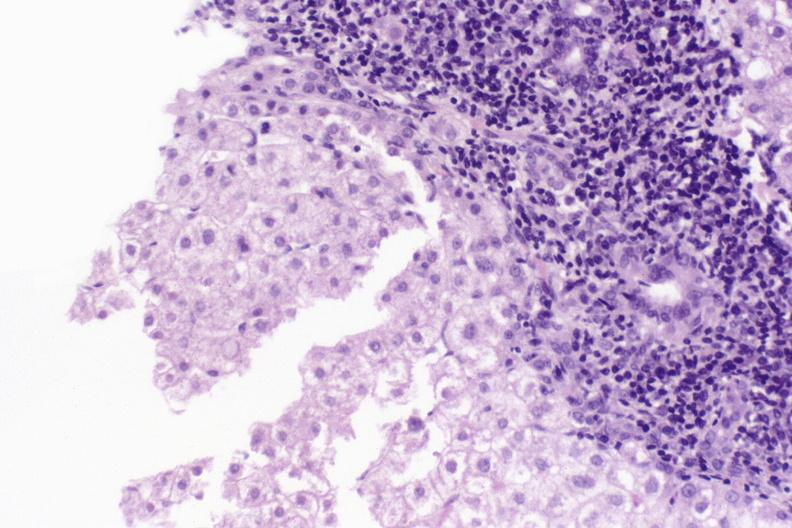s liver present?
Answer the question using a single word or phrase. Yes 